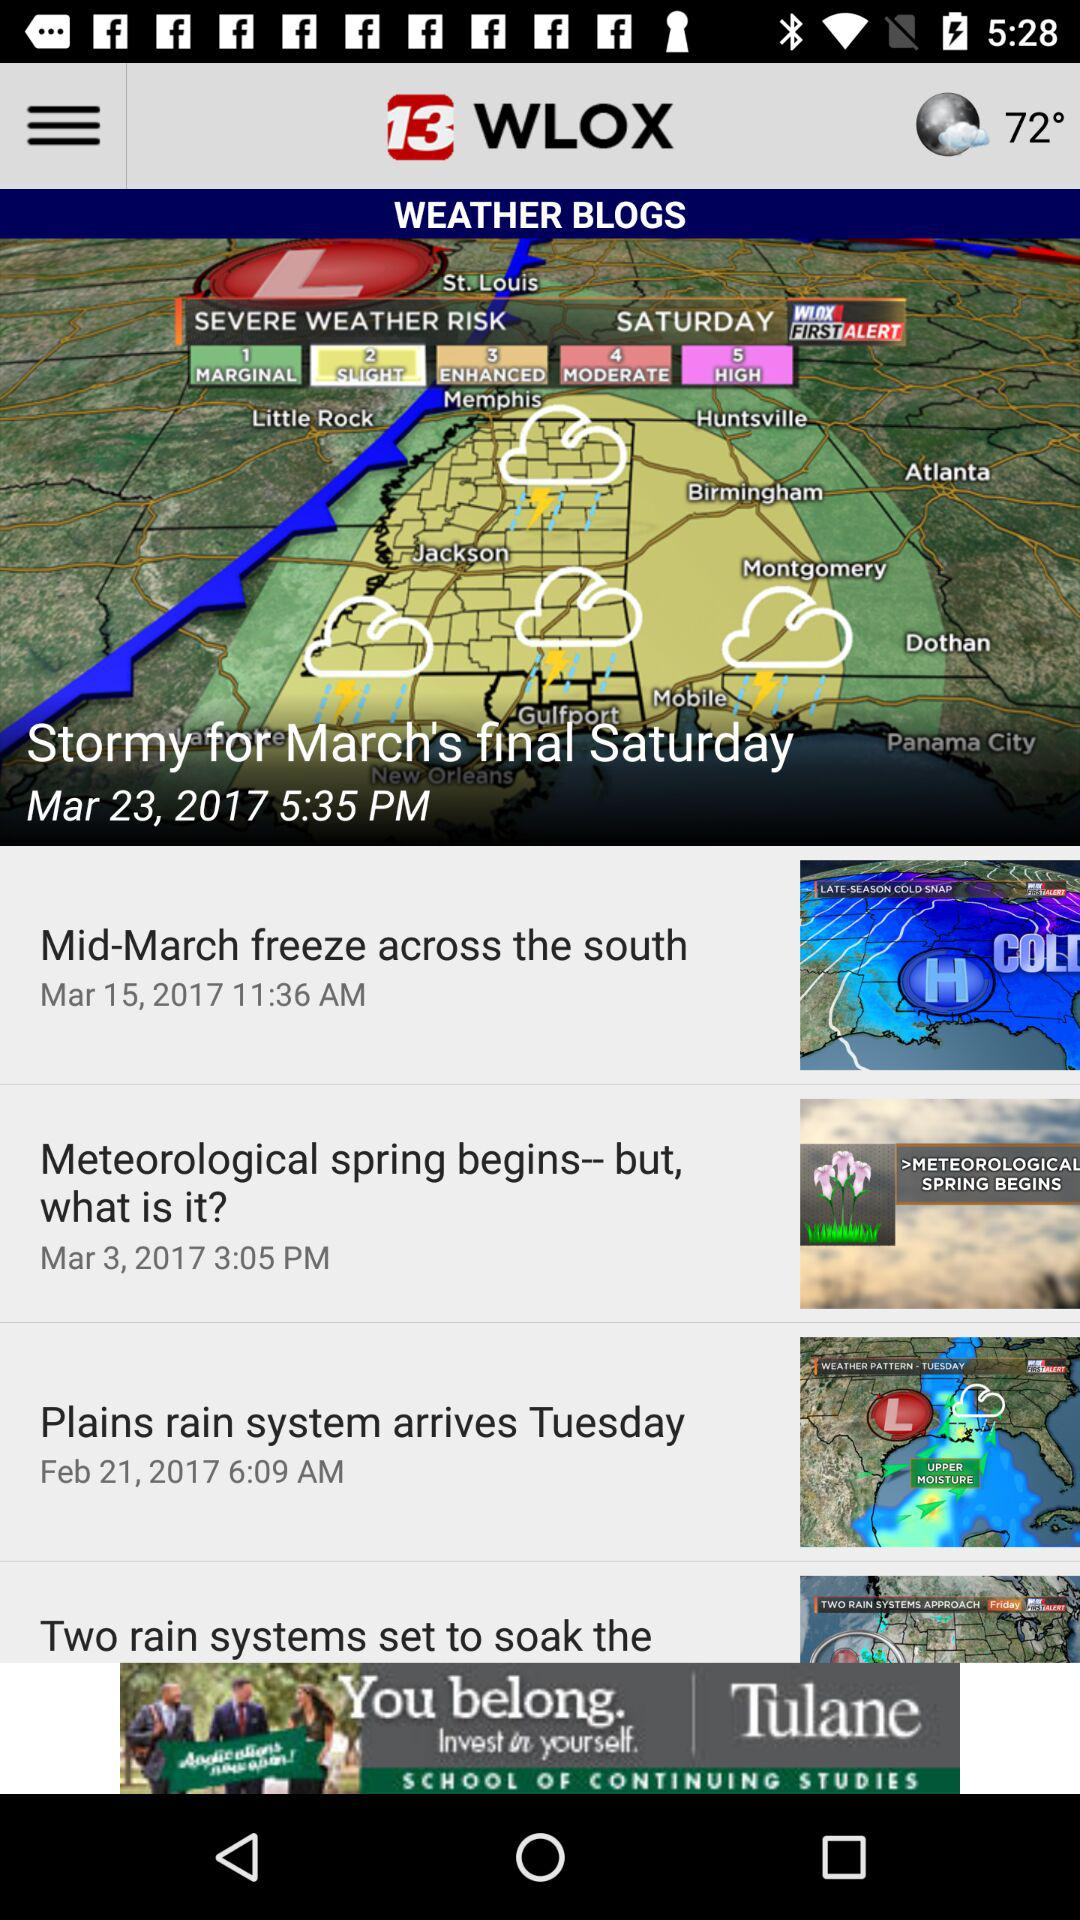What is the temperature? The temperature is 72°. 